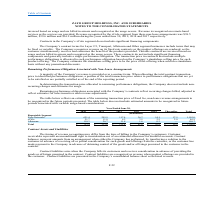According to Zayo Group Holdings's financial document, What do remaining performance obligations associated with the Company’s contracts reflect? recurring charges billed, adjusted to reflect estimates for sales incentives and revenue adjustments. The document states: "s associated with the Company’s contracts reflect recurring charges billed, adjusted to reflect estimates for sales incentives and revenue adjustments..." Also, What does the table below reflect? The table below reflects an estimate of the remaining transaction price of fixed fee, non-lease revenue arrangements to be recognized in the future periods presented.. The document states: "The table below reflects an estimate of the remaining transaction price of fixed fee, non-lease revenue arrangements to be recognized in the future pe..." Also, What does the company not include when determining the transaction price allocated to remaining performance obligations? the Company does not include non- recurring charges and estimates for usage. The document states: "e allocated to remaining performance obligations, the Company does not include non- recurring charges and estimates for usage...." Also, can you calculate: How much remaining transaction price of fixed fee, non-lease revenue arrangements does the company expect to recognize from Zayo Networks and zColo in 2020? Based on the calculation: 621.4+21.7, the result is 643.1 (in millions). This is based on the information: "zColo 21.7 11.0 6.2 3.5 2.5 2.0 46.9 Zayo Networks 621.4 295.9 117.4 36.7 14.1 17.5 1,103.0..." The key data points involved are: 21.7, 621.4. Additionally, Which reportable segment had the highest amount in 2024?  According to the financial document, Zayo Networks. The relevant text states: "Zayo Networks 621.4 295.9 117.4 36.7 14.1 17.5 1,103.0..." Additionally, In which years does the company expect Allstream to have amount of higher than 10 million? The document contains multiple relevant values: 2020, 2021, 2022. From the document: "2020 2021 2022 2023 2024 Thereafter Total 2020 2021 2022 2023 2024 Thereafter Total 2020 2021 2022 2023 2024 Thereafter Total..." 